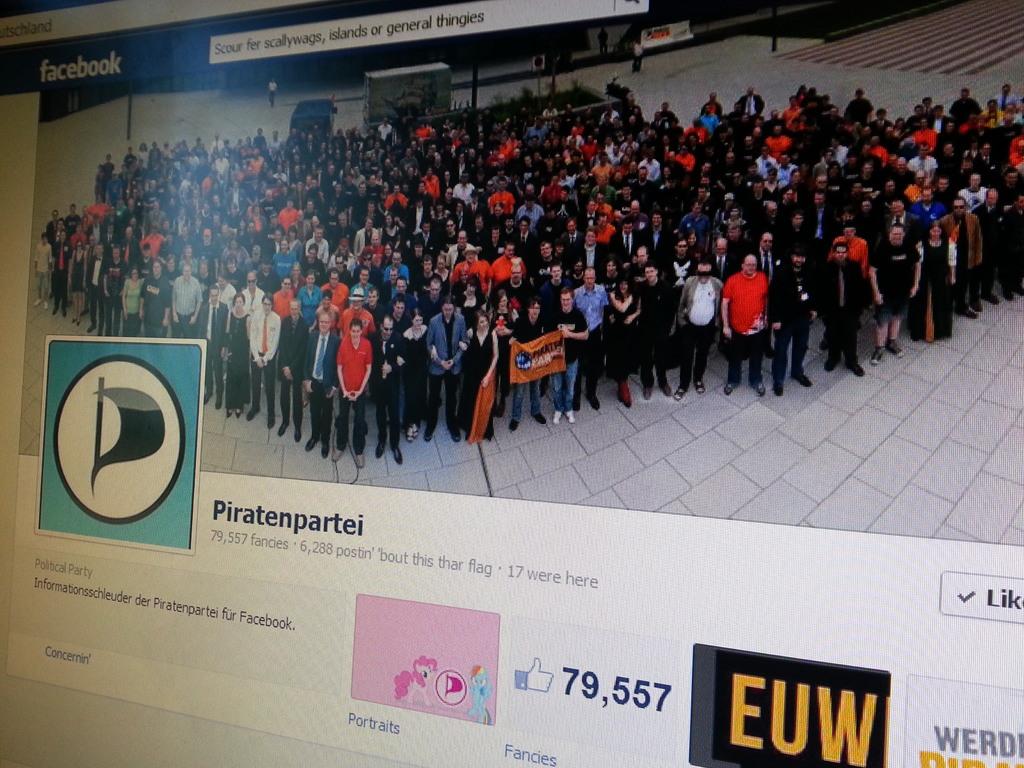What facebook group is this?
Provide a short and direct response. Piratenpartei. How many likes does this have?
Your response must be concise. 79,557. 